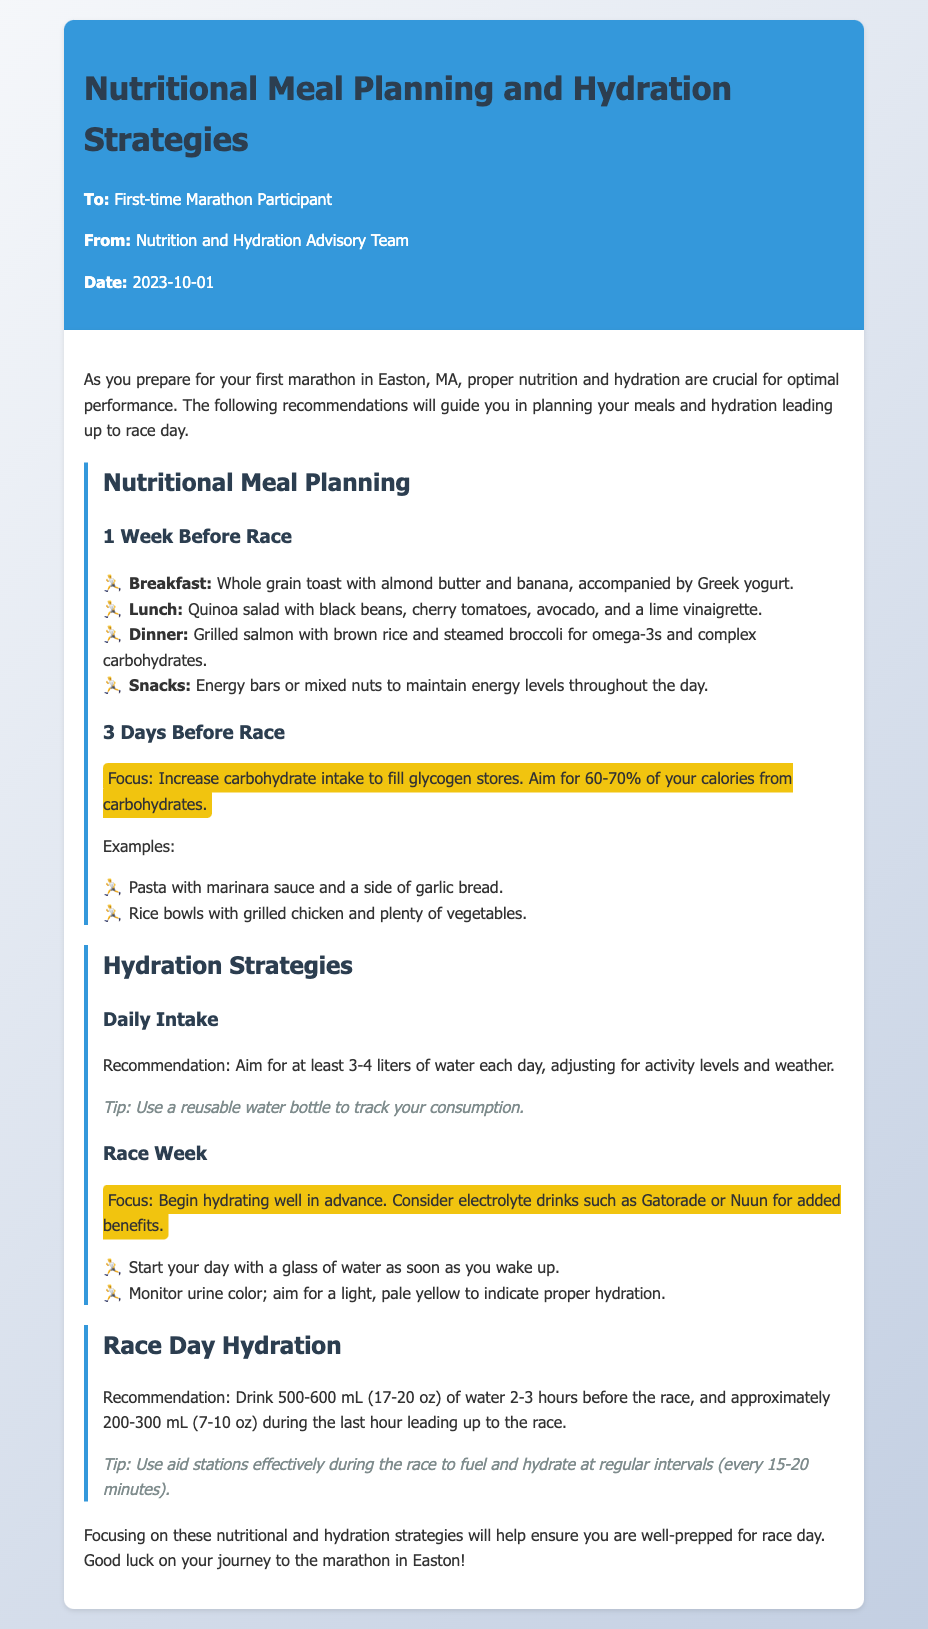what are the three meals recommended for one week before the race? The memo lists specific meals for breakfast, lunch, and dinner to eat one week before the race.
Answer: Whole grain toast with almond butter and banana; Quinoa salad with black beans, cherry tomatoes, and avocado; Grilled salmon with brown rice and steamed broccoli what percentage of calories should be from carbohydrates three days before the race? The document clearly states the percentage of calories that should come from carbohydrates three days before the race.
Answer: 60-70% how much water should you drink daily during race week? The memo provides a daily water intake recommendation during race week.
Answer: 3-4 liters what is a suggested snack to maintain energy levels throughout the day? The document mentions specific snacks recommended for energy maintenance.
Answer: Energy bars or mixed nuts how much water should be consumed 2-3 hours before the race? The memo specifies the amount of water recommended to drink before the race.
Answer: 500-600 mL (17-20 oz) what should the urine color indicate when monitoring hydration? The document indicates an appropriate urine color to signify proper hydration.
Answer: Light, pale yellow what is the purpose of electrolyte drinks mentioned in the memo? The memo includes a recommendation for electrolyte drinks and their benefits.
Answer: Added benefits what should be monitored to ensure adequate hydration? The memo suggests a specific aspect to monitor for hydration check.
Answer: Urine color 